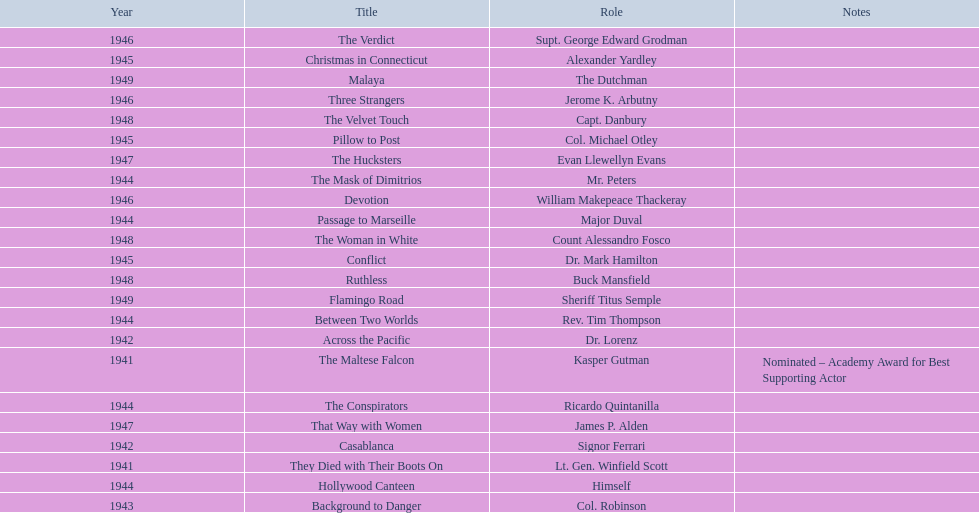What are all of the movies sydney greenstreet acted in? The Maltese Falcon, They Died with Their Boots On, Across the Pacific, Casablanca, Background to Danger, Passage to Marseille, Between Two Worlds, The Mask of Dimitrios, The Conspirators, Hollywood Canteen, Pillow to Post, Conflict, Christmas in Connecticut, Three Strangers, Devotion, The Verdict, That Way with Women, The Hucksters, The Velvet Touch, Ruthless, The Woman in White, Flamingo Road, Malaya. What are all of the title notes? Nominated – Academy Award for Best Supporting Actor. Which film was the award for? The Maltese Falcon. 